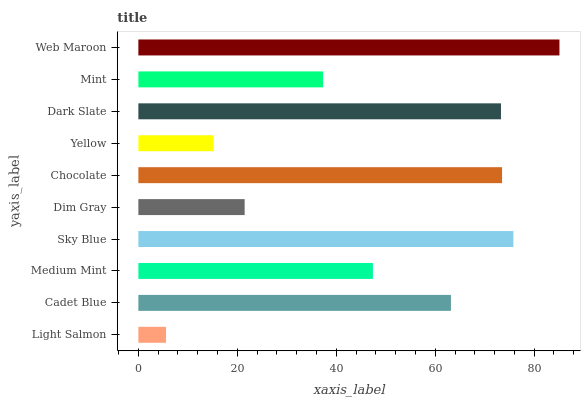Is Light Salmon the minimum?
Answer yes or no. Yes. Is Web Maroon the maximum?
Answer yes or no. Yes. Is Cadet Blue the minimum?
Answer yes or no. No. Is Cadet Blue the maximum?
Answer yes or no. No. Is Cadet Blue greater than Light Salmon?
Answer yes or no. Yes. Is Light Salmon less than Cadet Blue?
Answer yes or no. Yes. Is Light Salmon greater than Cadet Blue?
Answer yes or no. No. Is Cadet Blue less than Light Salmon?
Answer yes or no. No. Is Cadet Blue the high median?
Answer yes or no. Yes. Is Medium Mint the low median?
Answer yes or no. Yes. Is Chocolate the high median?
Answer yes or no. No. Is Yellow the low median?
Answer yes or no. No. 